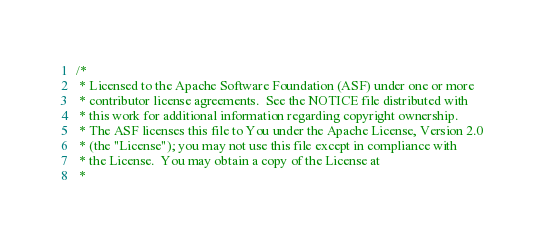<code> <loc_0><loc_0><loc_500><loc_500><_Scala_>/*
 * Licensed to the Apache Software Foundation (ASF) under one or more
 * contributor license agreements.  See the NOTICE file distributed with
 * this work for additional information regarding copyright ownership.
 * The ASF licenses this file to You under the Apache License, Version 2.0
 * (the "License"); you may not use this file except in compliance with
 * the License.  You may obtain a copy of the License at
 *</code> 